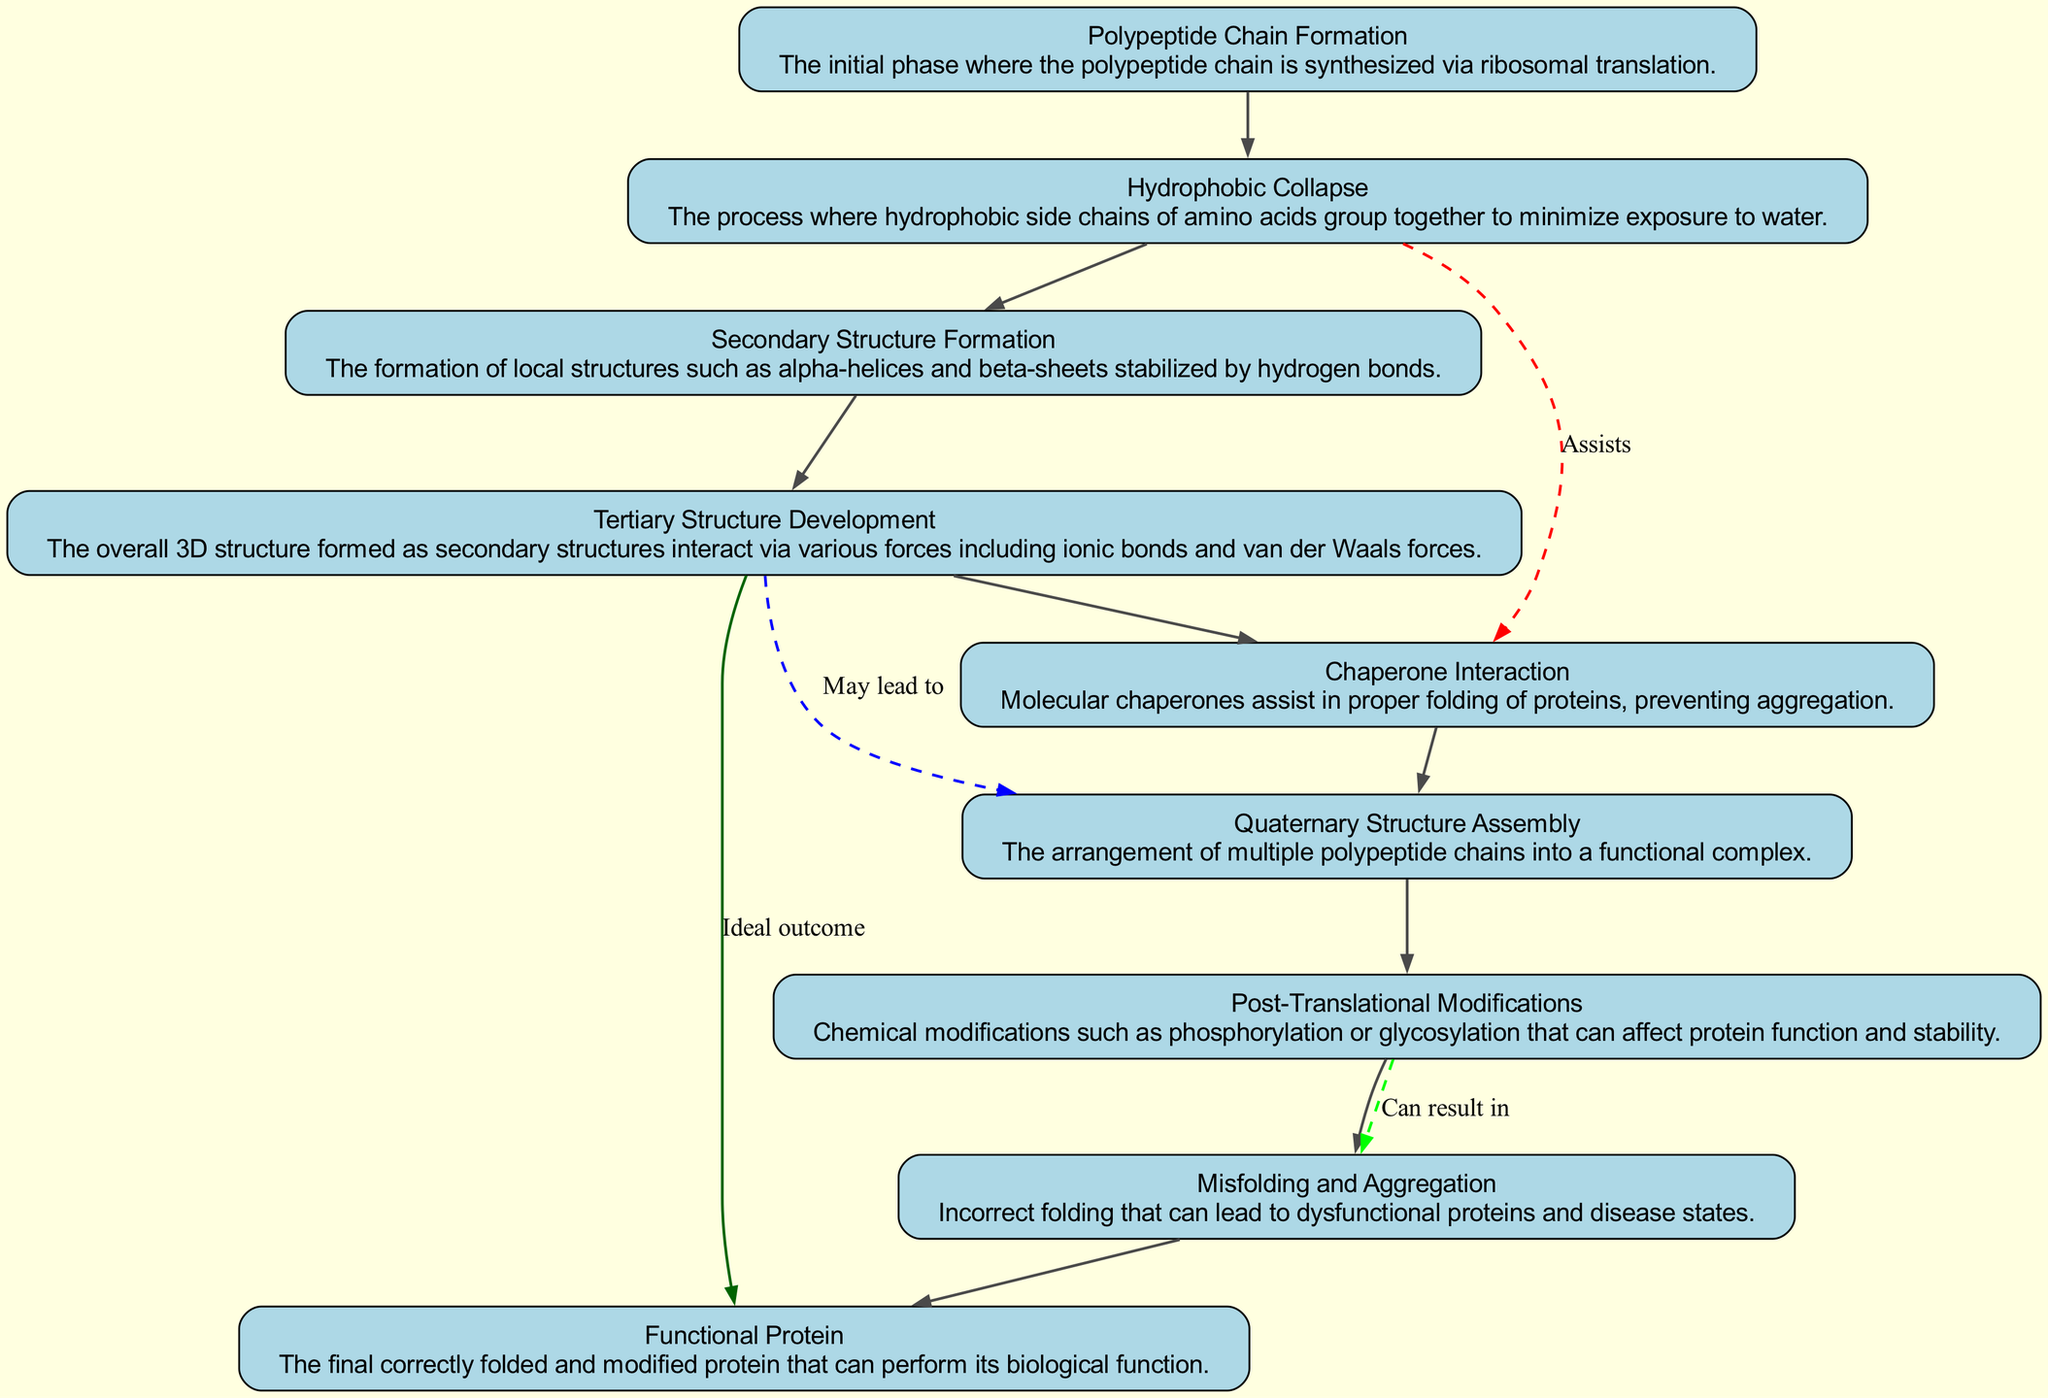What is the initial phase of protein folding? The diagram indicates that the initial phase of protein folding is referred to as "Polypeptide Chain Formation." This corresponds to the first node in the flow chart.
Answer: Polypeptide Chain Formation Which molecular interaction occurs between hydrophobic side chains? According to the diagram, the interaction that occurs between hydrophobic side chains is described as "Hydrophobic Collapse." This process is depicted as the second node in the flow.
Answer: Hydrophobic Collapse How many main stages are presented in the folding pathway? By counting the nodes in the diagram, we observe there are nine main stages highlighted in the flow of molecular interactions during protein folding.
Answer: Nine Which stage is assisted by molecular chaperones? The diagram states that "Chaperone Interaction" assists the folding process. This step is indicated by the relationship from the hydrophobic collapse to tertiary structure development.
Answer: Chaperone Interaction What is the ideal outcome of the folding process? The ideal outcome, as depicted in the diagram, is to achieve a "Functional Protein." This is linked as the final desirable state resulting from proper folding.
Answer: Functional Protein What follows the secondary structure formation? The diagram shows that "Tertiary Structure Development" occurs after the "Secondary Structure Formation." This is indicated by the direct connection between these two nodes.
Answer: Tertiary Structure Development Which process can result in dysfunctional proteins? The diagram indicates that "Misfolding and Aggregation" can lead to dysfunctional proteins. This is highlighted as a consequence of incorrect folding.
Answer: Misfolding and Aggregation What kind of modifications occur after protein folding? According to the diagram, "Post-Translational Modifications" take place after the initial folding stages, leading to further adjustments in the protein's structure and function.
Answer: Post-Translational Modifications Which node has a dashed red edge indicating assistance? The dashed red edge from "Hydrophobic Collapse" to "Tertiary Structure Development" indicates that this stage is "Assisted" by molecular chaperones. The color and style of the edge denote this specific support.
Answer: Tertiary Structure Development 